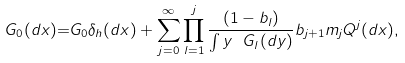<formula> <loc_0><loc_0><loc_500><loc_500>\ G _ { 0 } ( d x ) { = } G _ { 0 } \delta _ { h } ( d x ) + \sum _ { j = 0 } ^ { \infty } \prod _ { l = 1 } ^ { j } \frac { ( 1 - b _ { l } ) } { \int y \ G _ { l } ( d y ) } b _ { j + 1 } m _ { j } Q ^ { j } ( d x ) ,</formula> 